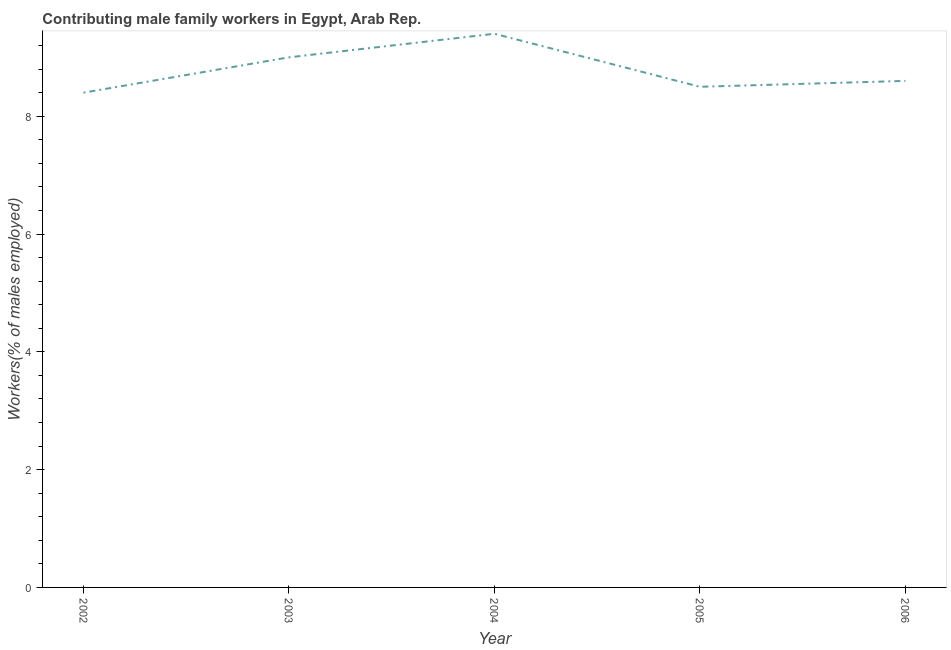Across all years, what is the maximum contributing male family workers?
Offer a terse response. 9.4. Across all years, what is the minimum contributing male family workers?
Provide a succinct answer. 8.4. What is the sum of the contributing male family workers?
Make the answer very short. 43.9. What is the difference between the contributing male family workers in 2002 and 2003?
Keep it short and to the point. -0.6. What is the average contributing male family workers per year?
Your response must be concise. 8.78. What is the median contributing male family workers?
Provide a short and direct response. 8.6. In how many years, is the contributing male family workers greater than 7.2 %?
Your answer should be very brief. 5. Do a majority of the years between 2004 and 2003 (inclusive) have contributing male family workers greater than 3.6 %?
Keep it short and to the point. No. What is the ratio of the contributing male family workers in 2002 to that in 2003?
Offer a very short reply. 0.93. Is the difference between the contributing male family workers in 2002 and 2003 greater than the difference between any two years?
Your answer should be compact. No. What is the difference between the highest and the second highest contributing male family workers?
Keep it short and to the point. 0.4. Is the sum of the contributing male family workers in 2003 and 2004 greater than the maximum contributing male family workers across all years?
Ensure brevity in your answer.  Yes. What is the difference between the highest and the lowest contributing male family workers?
Provide a short and direct response. 1. In how many years, is the contributing male family workers greater than the average contributing male family workers taken over all years?
Provide a short and direct response. 2. Does the contributing male family workers monotonically increase over the years?
Your answer should be compact. No. How many lines are there?
Offer a very short reply. 1. How many years are there in the graph?
Offer a very short reply. 5. What is the difference between two consecutive major ticks on the Y-axis?
Provide a short and direct response. 2. What is the title of the graph?
Provide a succinct answer. Contributing male family workers in Egypt, Arab Rep. What is the label or title of the X-axis?
Give a very brief answer. Year. What is the label or title of the Y-axis?
Provide a short and direct response. Workers(% of males employed). What is the Workers(% of males employed) in 2002?
Your response must be concise. 8.4. What is the Workers(% of males employed) in 2003?
Provide a short and direct response. 9. What is the Workers(% of males employed) in 2004?
Your response must be concise. 9.4. What is the Workers(% of males employed) in 2006?
Your answer should be compact. 8.6. What is the difference between the Workers(% of males employed) in 2002 and 2004?
Offer a terse response. -1. What is the difference between the Workers(% of males employed) in 2002 and 2005?
Your answer should be very brief. -0.1. What is the difference between the Workers(% of males employed) in 2002 and 2006?
Give a very brief answer. -0.2. What is the difference between the Workers(% of males employed) in 2003 and 2005?
Offer a terse response. 0.5. What is the difference between the Workers(% of males employed) in 2003 and 2006?
Keep it short and to the point. 0.4. What is the difference between the Workers(% of males employed) in 2004 and 2005?
Offer a very short reply. 0.9. What is the ratio of the Workers(% of males employed) in 2002 to that in 2003?
Your answer should be very brief. 0.93. What is the ratio of the Workers(% of males employed) in 2002 to that in 2004?
Provide a short and direct response. 0.89. What is the ratio of the Workers(% of males employed) in 2002 to that in 2006?
Ensure brevity in your answer.  0.98. What is the ratio of the Workers(% of males employed) in 2003 to that in 2005?
Provide a succinct answer. 1.06. What is the ratio of the Workers(% of males employed) in 2003 to that in 2006?
Provide a succinct answer. 1.05. What is the ratio of the Workers(% of males employed) in 2004 to that in 2005?
Offer a very short reply. 1.11. What is the ratio of the Workers(% of males employed) in 2004 to that in 2006?
Your response must be concise. 1.09. 